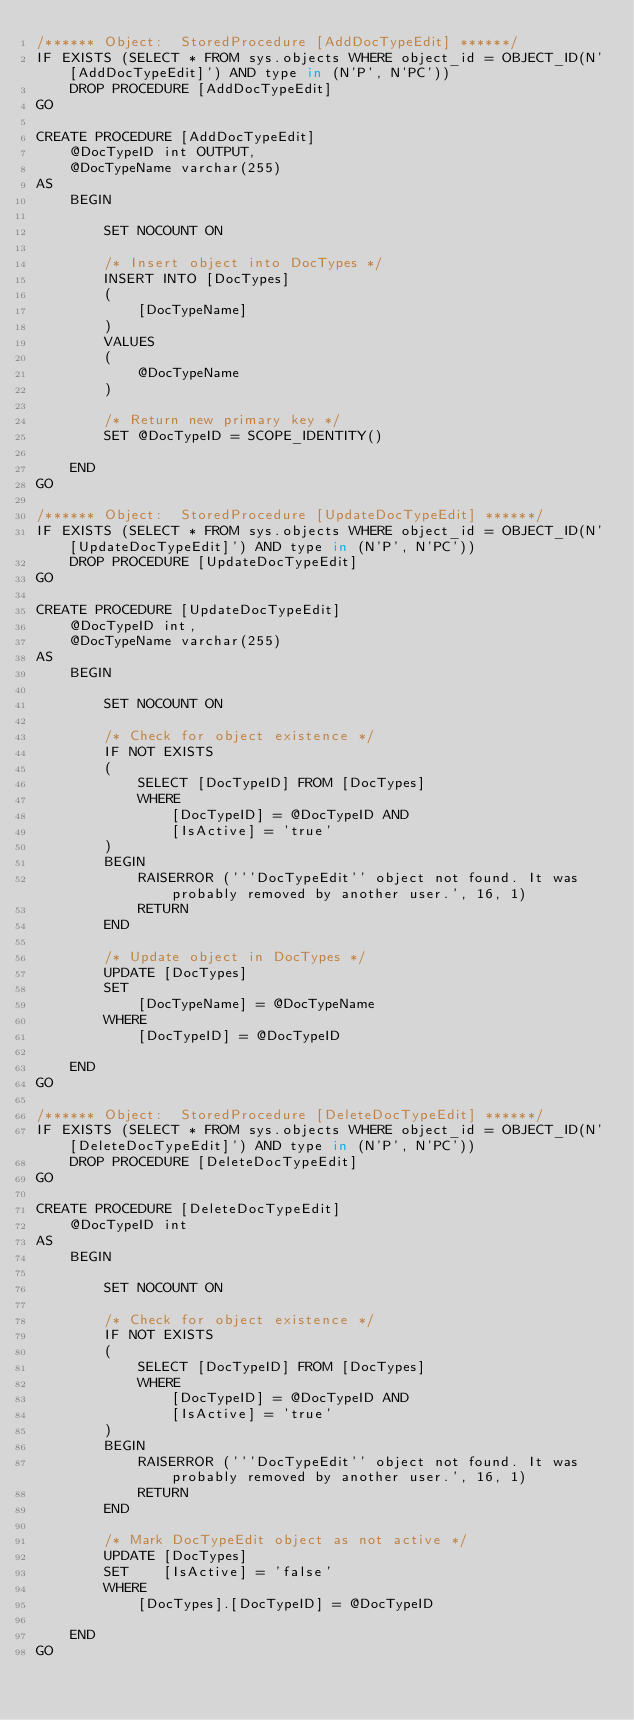<code> <loc_0><loc_0><loc_500><loc_500><_SQL_>/****** Object:  StoredProcedure [AddDocTypeEdit] ******/
IF EXISTS (SELECT * FROM sys.objects WHERE object_id = OBJECT_ID(N'[AddDocTypeEdit]') AND type in (N'P', N'PC'))
    DROP PROCEDURE [AddDocTypeEdit]
GO

CREATE PROCEDURE [AddDocTypeEdit]
    @DocTypeID int OUTPUT,
    @DocTypeName varchar(255)
AS
    BEGIN

        SET NOCOUNT ON

        /* Insert object into DocTypes */
        INSERT INTO [DocTypes]
        (
            [DocTypeName]
        )
        VALUES
        (
            @DocTypeName
        )

        /* Return new primary key */
        SET @DocTypeID = SCOPE_IDENTITY()

    END
GO

/****** Object:  StoredProcedure [UpdateDocTypeEdit] ******/
IF EXISTS (SELECT * FROM sys.objects WHERE object_id = OBJECT_ID(N'[UpdateDocTypeEdit]') AND type in (N'P', N'PC'))
    DROP PROCEDURE [UpdateDocTypeEdit]
GO

CREATE PROCEDURE [UpdateDocTypeEdit]
    @DocTypeID int,
    @DocTypeName varchar(255)
AS
    BEGIN

        SET NOCOUNT ON

        /* Check for object existence */
        IF NOT EXISTS
        (
            SELECT [DocTypeID] FROM [DocTypes]
            WHERE
                [DocTypeID] = @DocTypeID AND
                [IsActive] = 'true'
        )
        BEGIN
            RAISERROR ('''DocTypeEdit'' object not found. It was probably removed by another user.', 16, 1)
            RETURN
        END

        /* Update object in DocTypes */
        UPDATE [DocTypes]
        SET
            [DocTypeName] = @DocTypeName
        WHERE
            [DocTypeID] = @DocTypeID

    END
GO

/****** Object:  StoredProcedure [DeleteDocTypeEdit] ******/
IF EXISTS (SELECT * FROM sys.objects WHERE object_id = OBJECT_ID(N'[DeleteDocTypeEdit]') AND type in (N'P', N'PC'))
    DROP PROCEDURE [DeleteDocTypeEdit]
GO

CREATE PROCEDURE [DeleteDocTypeEdit]
    @DocTypeID int
AS
    BEGIN

        SET NOCOUNT ON

        /* Check for object existence */
        IF NOT EXISTS
        (
            SELECT [DocTypeID] FROM [DocTypes]
            WHERE
                [DocTypeID] = @DocTypeID AND
                [IsActive] = 'true'
        )
        BEGIN
            RAISERROR ('''DocTypeEdit'' object not found. It was probably removed by another user.', 16, 1)
            RETURN
        END

        /* Mark DocTypeEdit object as not active */
        UPDATE [DocTypes]
        SET    [IsActive] = 'false'
        WHERE
            [DocTypes].[DocTypeID] = @DocTypeID

    END
GO
</code> 